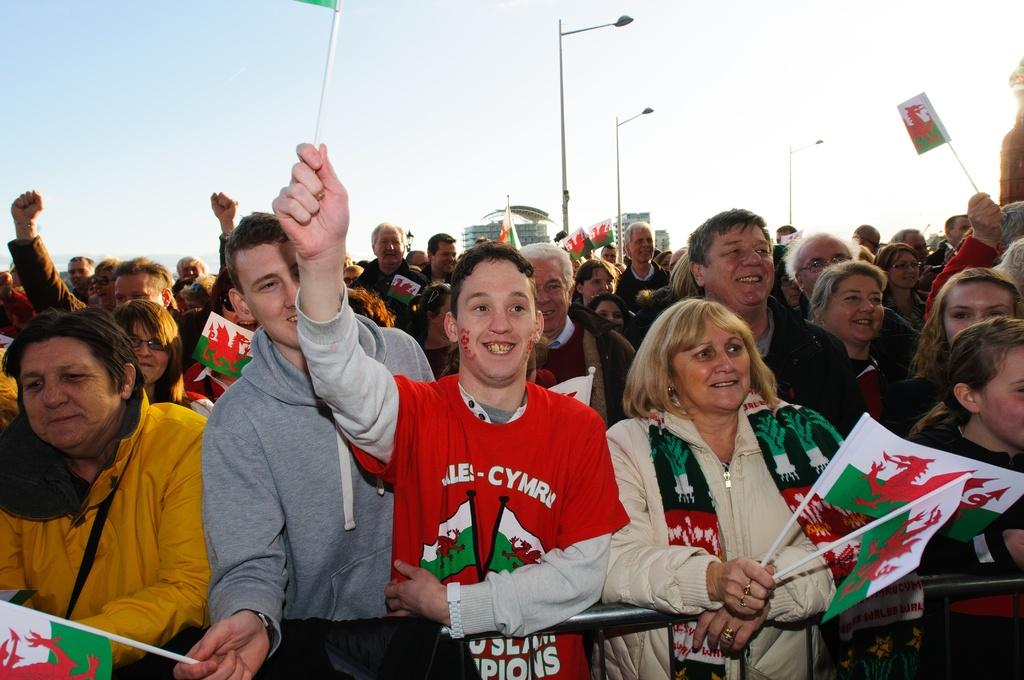How many people are in the image? There is a group of people standing in the image, but the exact number cannot be determined from the provided facts. What can be seen in the image besides the group of people? There are flags, a fence, poles, lamps, buildings, and the sky visible in the image. What might be used to separate or enclose areas in the image? The fence in the image might be used to separate or enclose areas. What is visible in the background of the image? The sky is visible in the background of the image. What type of organization is being held in the hall during the summer in the image? There is no hall or summer event mentioned in the image; it only features a group of people, flags, a fence, poles, lamps, buildings, and the sky. 